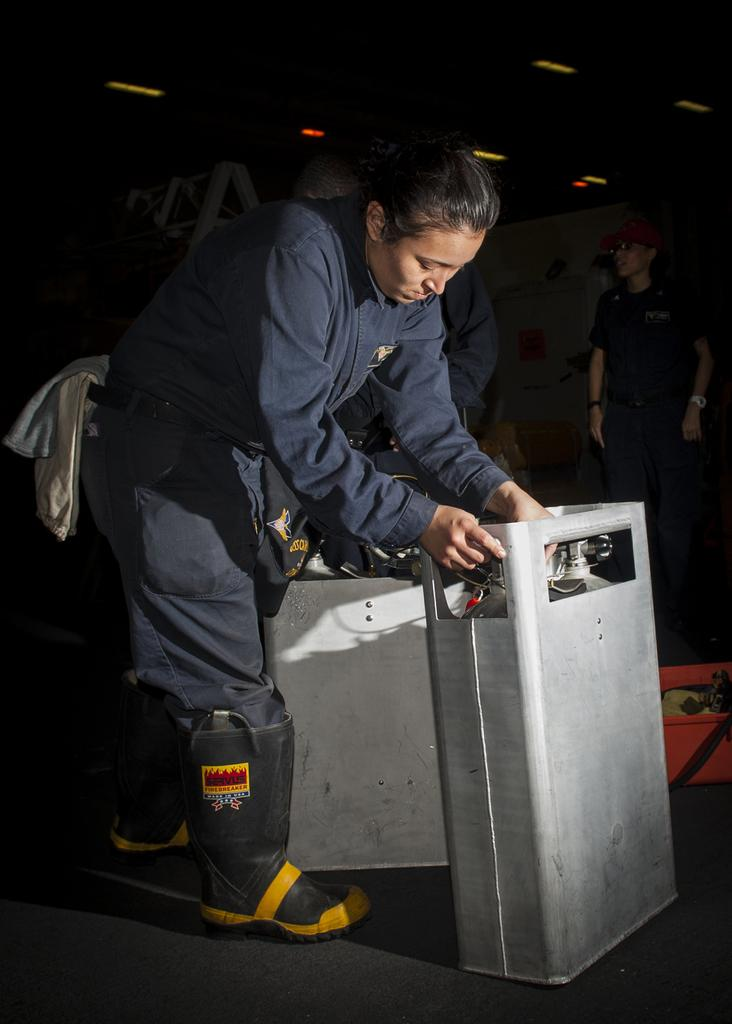Who is the main subject in the foreground of the image? There is a lady in the foreground of the image. What is the lady wearing? The lady is wearing a blue suit. What is the lady holding in the image? The lady is holding a machine. Can you describe the background of the image? There are other people in the background of the image. What can be seen on the ceiling in the image? There are lights on the ceiling in the image. What type of attraction can be seen in the image? There is no attraction present in the image; it features a lady holding a machine and other people in the background. Can you see any bats flying in the image? There are no bats visible in the image. 